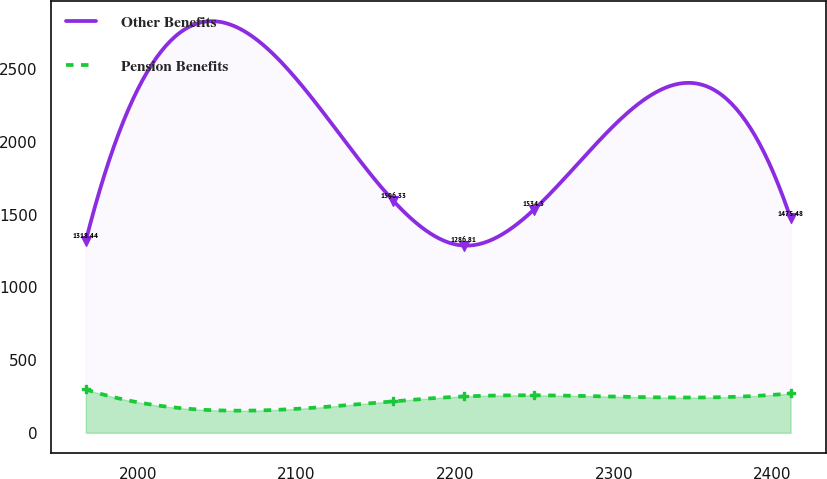<chart> <loc_0><loc_0><loc_500><loc_500><line_chart><ecel><fcel>Other Benefits<fcel>Pension Benefits<nl><fcel>1967.11<fcel>1318.44<fcel>297.65<nl><fcel>2160.79<fcel>1596.33<fcel>216.65<nl><fcel>2205.21<fcel>1286.81<fcel>249.42<nl><fcel>2249.63<fcel>1534.5<fcel>257.52<nl><fcel>2411.33<fcel>1475.48<fcel>270.31<nl></chart> 